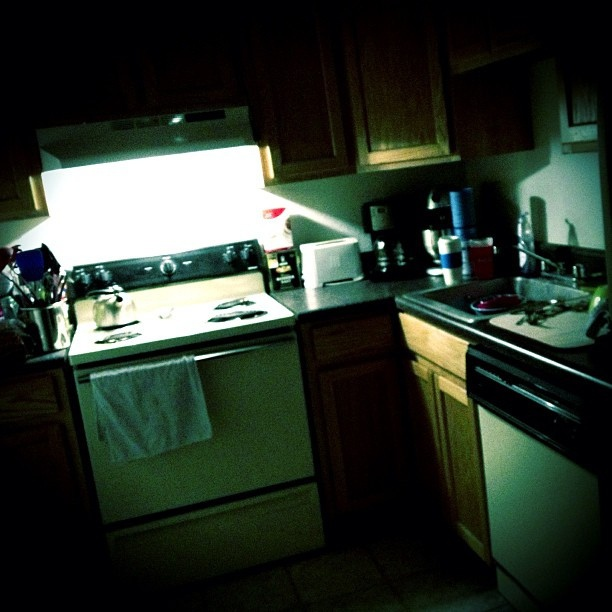Describe the objects in this image and their specific colors. I can see oven in black, darkgreen, ivory, and teal tones, sink in black, teal, and darkgreen tones, sink in black and teal tones, toaster in black, ivory, darkgray, and teal tones, and bottle in black, teal, and lightblue tones in this image. 